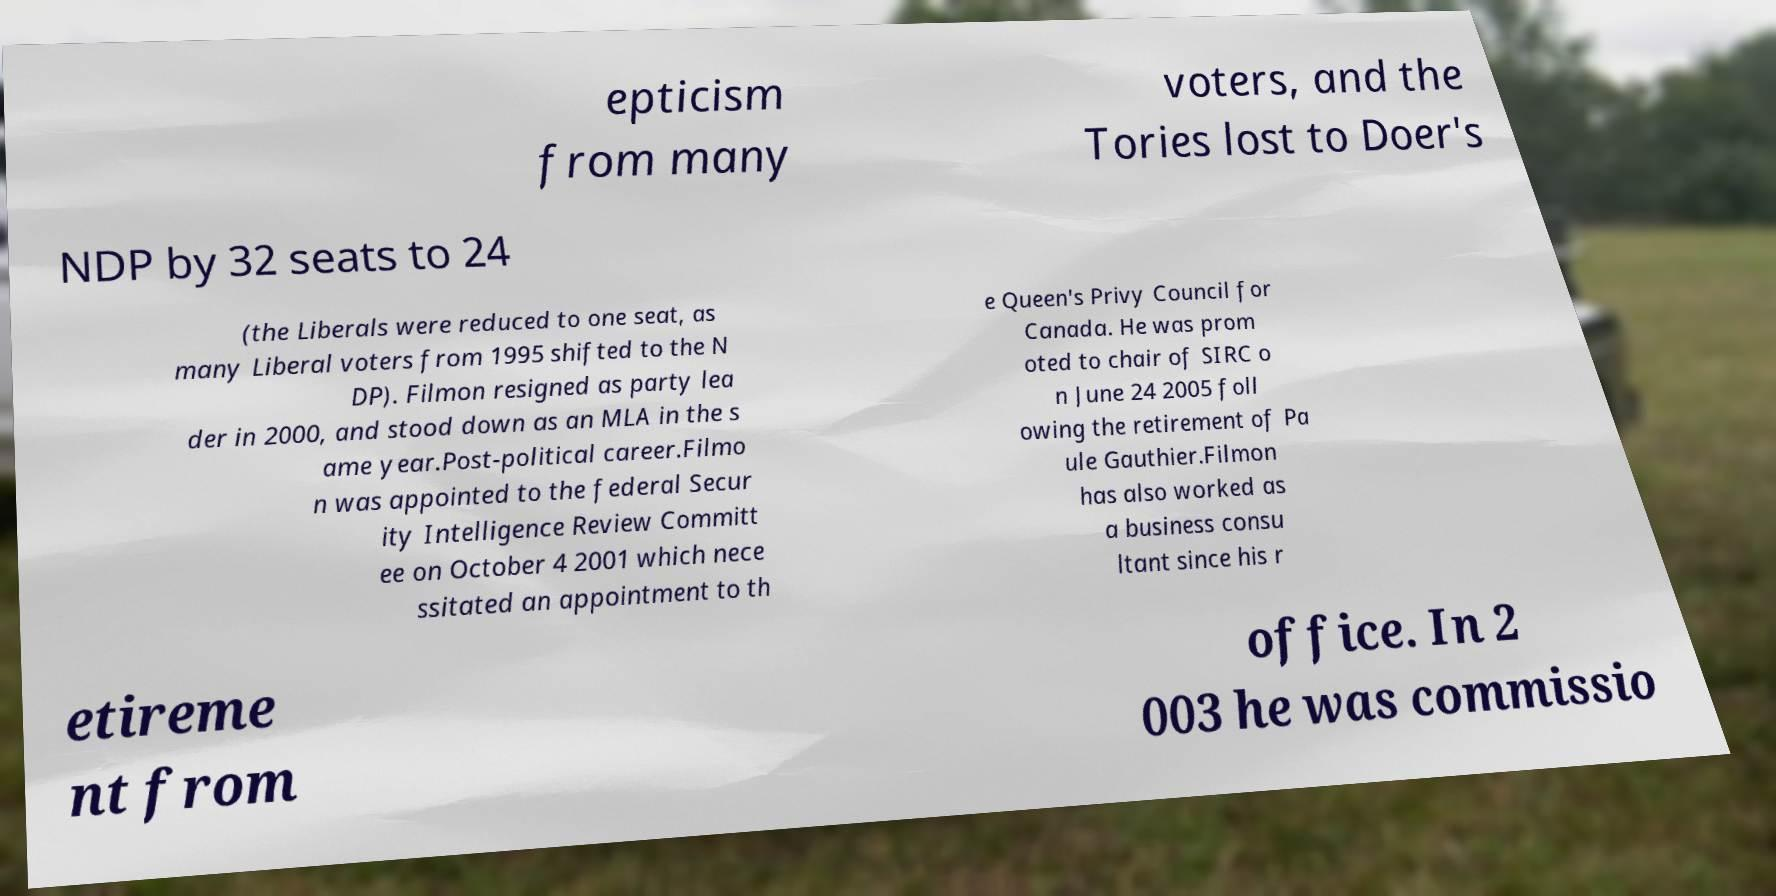Can you accurately transcribe the text from the provided image for me? epticism from many voters, and the Tories lost to Doer's NDP by 32 seats to 24 (the Liberals were reduced to one seat, as many Liberal voters from 1995 shifted to the N DP). Filmon resigned as party lea der in 2000, and stood down as an MLA in the s ame year.Post-political career.Filmo n was appointed to the federal Secur ity Intelligence Review Committ ee on October 4 2001 which nece ssitated an appointment to th e Queen's Privy Council for Canada. He was prom oted to chair of SIRC o n June 24 2005 foll owing the retirement of Pa ule Gauthier.Filmon has also worked as a business consu ltant since his r etireme nt from office. In 2 003 he was commissio 